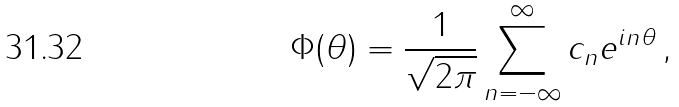Convert formula to latex. <formula><loc_0><loc_0><loc_500><loc_500>\Phi ( \theta ) = \frac { 1 } { \sqrt { 2 \pi } } \sum _ { n = - \infty } ^ { \infty } c _ { n } e ^ { i n \theta } \, ,</formula> 